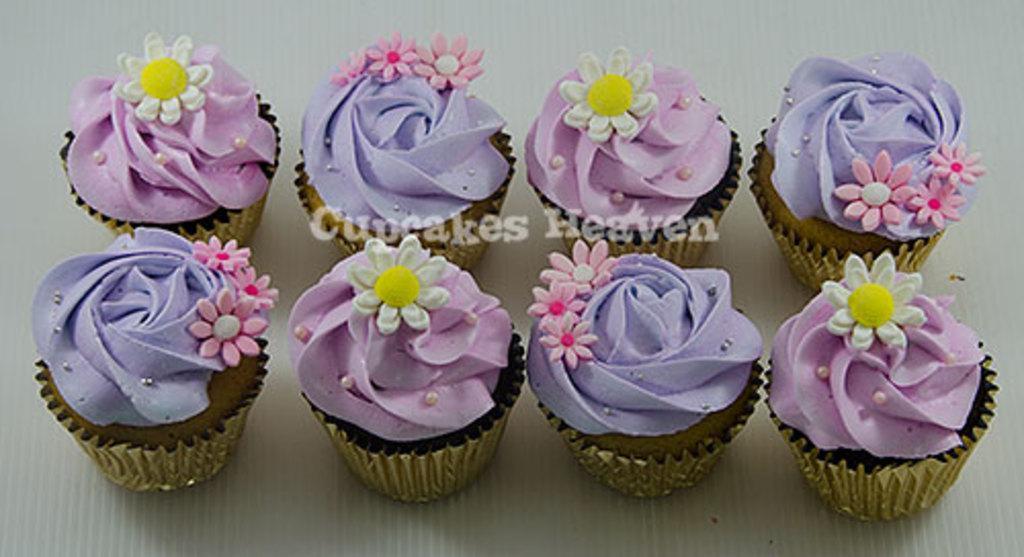How would you summarize this image in a sentence or two? In this picture, we see eight cupcakes and the cream of the cakes are in purple and violet color. In the background, it is white in color. 